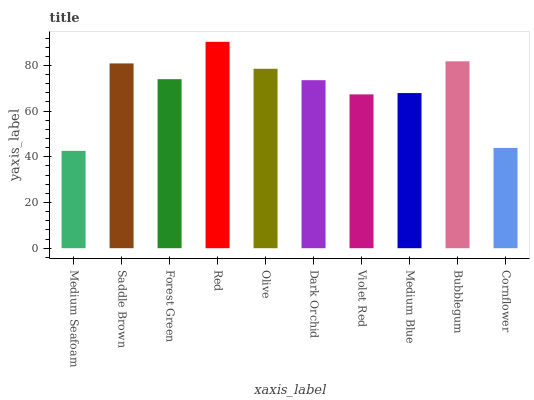Is Medium Seafoam the minimum?
Answer yes or no. Yes. Is Red the maximum?
Answer yes or no. Yes. Is Saddle Brown the minimum?
Answer yes or no. No. Is Saddle Brown the maximum?
Answer yes or no. No. Is Saddle Brown greater than Medium Seafoam?
Answer yes or no. Yes. Is Medium Seafoam less than Saddle Brown?
Answer yes or no. Yes. Is Medium Seafoam greater than Saddle Brown?
Answer yes or no. No. Is Saddle Brown less than Medium Seafoam?
Answer yes or no. No. Is Forest Green the high median?
Answer yes or no. Yes. Is Dark Orchid the low median?
Answer yes or no. Yes. Is Dark Orchid the high median?
Answer yes or no. No. Is Violet Red the low median?
Answer yes or no. No. 